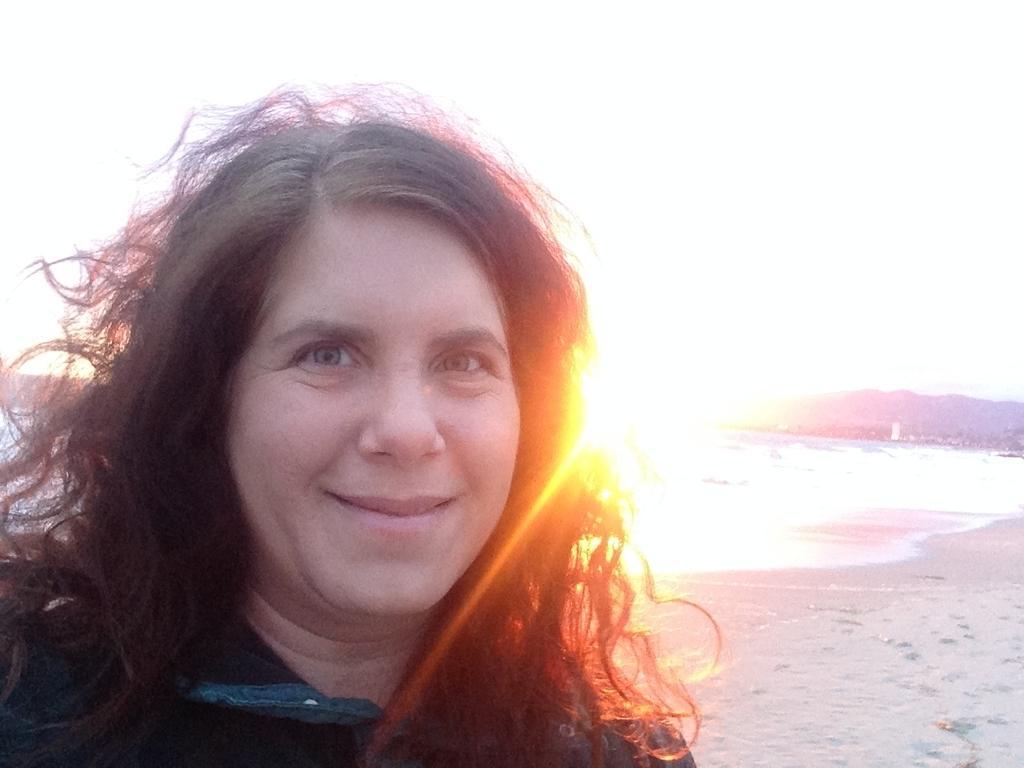Could you give a brief overview of what you see in this image? In this picture we can see a woman is smiling and standing on the path. Behind the women there are hills, water and a sky. 